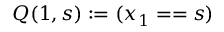<formula> <loc_0><loc_0><loc_500><loc_500>Q ( 1 , s ) \colon = ( x _ { 1 } = = s )</formula> 